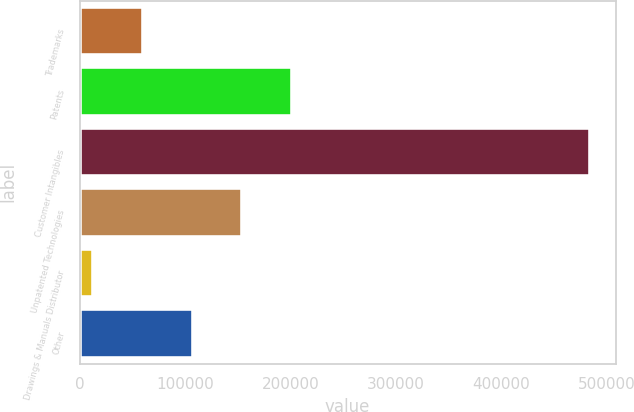<chart> <loc_0><loc_0><loc_500><loc_500><bar_chart><fcel>Trademarks<fcel>Patents<fcel>Customer Intangibles<fcel>Unpatented Technologies<fcel>Drawings & Manuals Distributor<fcel>Other<nl><fcel>60223.2<fcel>201632<fcel>484449<fcel>154496<fcel>13087<fcel>107359<nl></chart> 